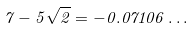Convert formula to latex. <formula><loc_0><loc_0><loc_500><loc_500>7 - 5 \sqrt { 2 } = - 0 . 0 7 1 0 6 \dots</formula> 